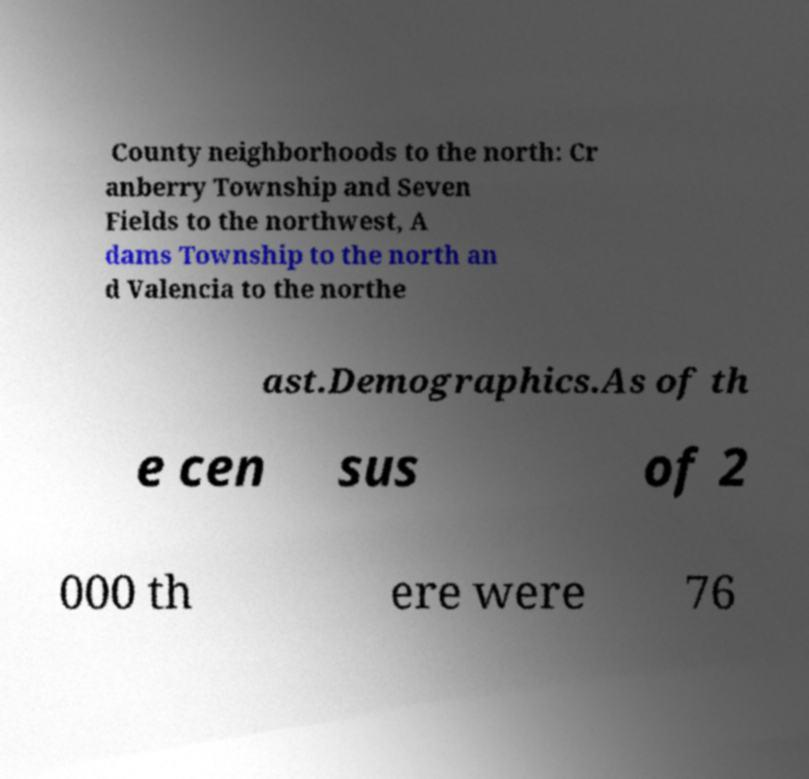Please read and relay the text visible in this image. What does it say? County neighborhoods to the north: Cr anberry Township and Seven Fields to the northwest, A dams Township to the north an d Valencia to the northe ast.Demographics.As of th e cen sus of 2 000 th ere were 76 